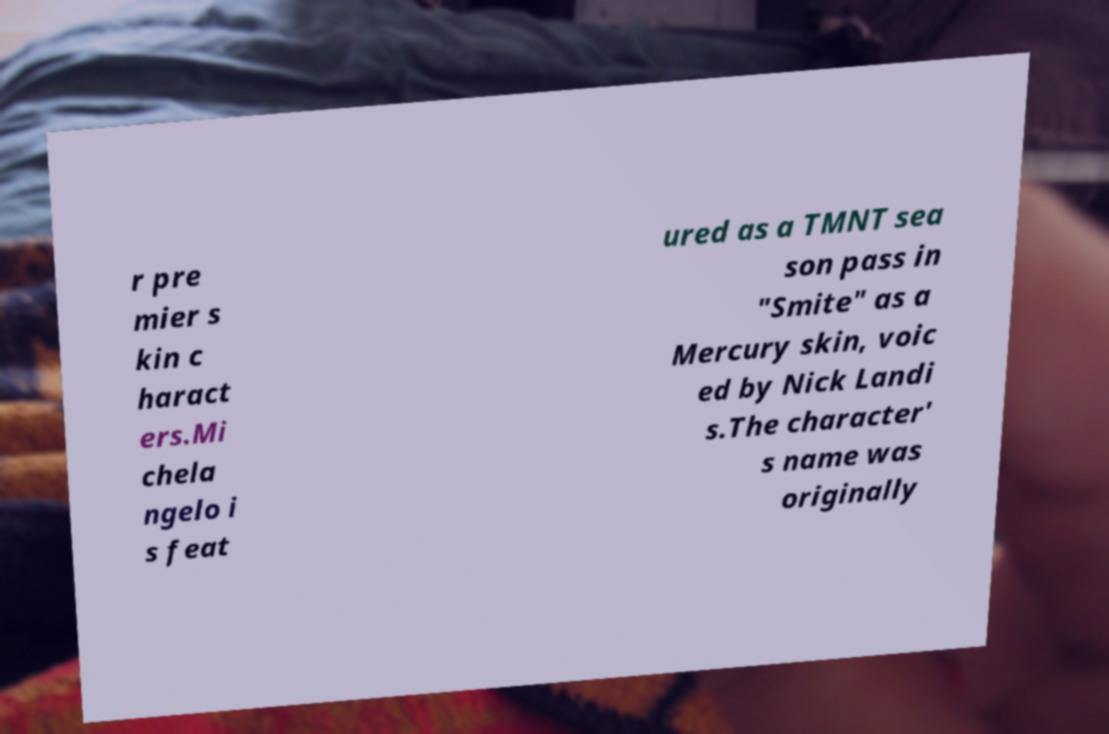Please identify and transcribe the text found in this image. r pre mier s kin c haract ers.Mi chela ngelo i s feat ured as a TMNT sea son pass in "Smite" as a Mercury skin, voic ed by Nick Landi s.The character' s name was originally 